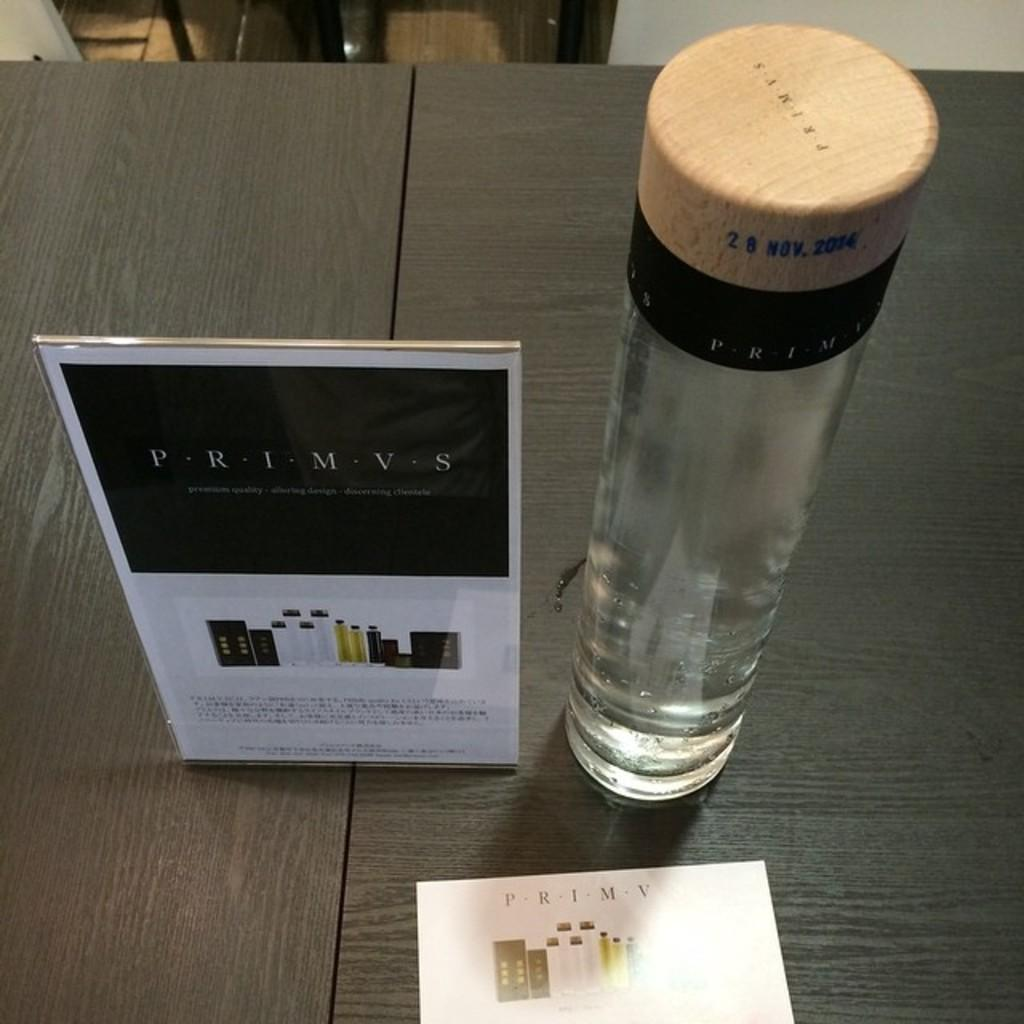<image>
Share a concise interpretation of the image provided. A glass container is next to an advertisement for Primvs. 